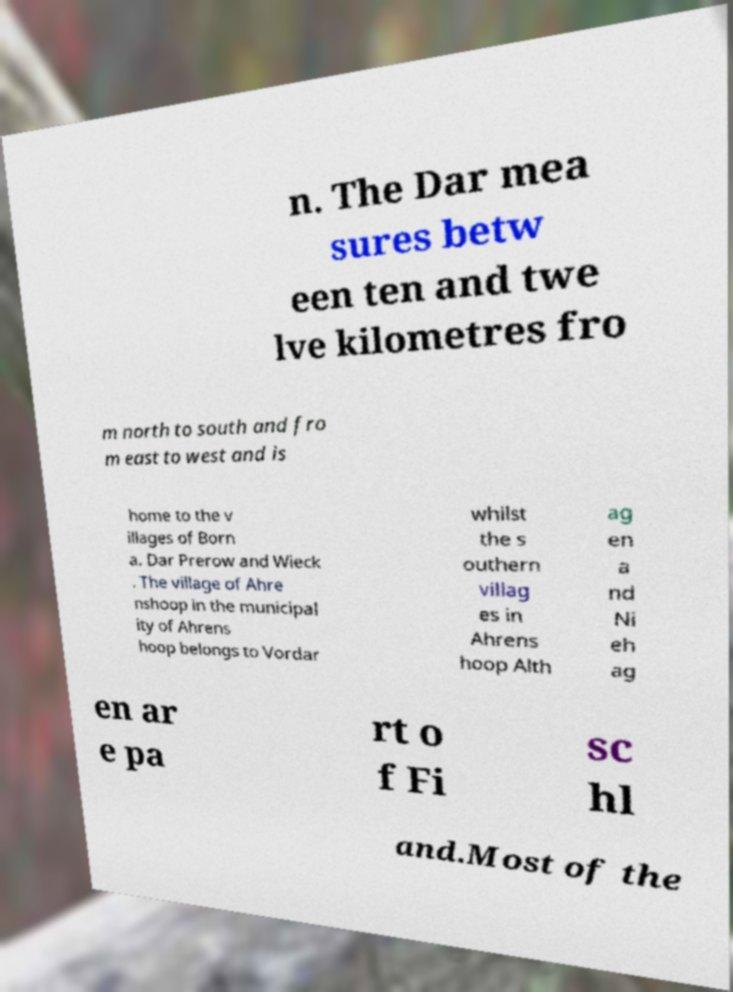Could you extract and type out the text from this image? n. The Dar mea sures betw een ten and twe lve kilometres fro m north to south and fro m east to west and is home to the v illages of Born a. Dar Prerow and Wieck . The village of Ahre nshoop in the municipal ity of Ahrens hoop belongs to Vordar whilst the s outhern villag es in Ahrens hoop Alth ag en a nd Ni eh ag en ar e pa rt o f Fi sc hl and.Most of the 